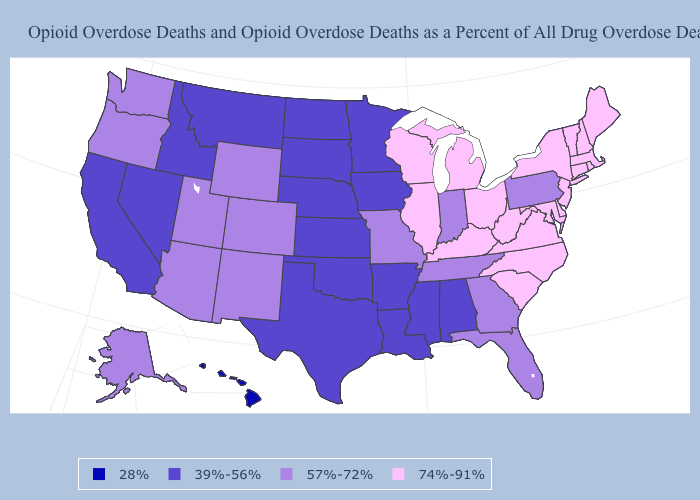What is the value of Virginia?
Short answer required. 74%-91%. What is the lowest value in the USA?
Short answer required. 28%. Name the states that have a value in the range 28%?
Give a very brief answer. Hawaii. Which states hav the highest value in the Northeast?
Write a very short answer. Connecticut, Maine, Massachusetts, New Hampshire, New Jersey, New York, Rhode Island, Vermont. Name the states that have a value in the range 39%-56%?
Give a very brief answer. Alabama, Arkansas, California, Idaho, Iowa, Kansas, Louisiana, Minnesota, Mississippi, Montana, Nebraska, Nevada, North Dakota, Oklahoma, South Dakota, Texas. Name the states that have a value in the range 57%-72%?
Keep it brief. Alaska, Arizona, Colorado, Florida, Georgia, Indiana, Missouri, New Mexico, Oregon, Pennsylvania, Tennessee, Utah, Washington, Wyoming. Name the states that have a value in the range 74%-91%?
Short answer required. Connecticut, Delaware, Illinois, Kentucky, Maine, Maryland, Massachusetts, Michigan, New Hampshire, New Jersey, New York, North Carolina, Ohio, Rhode Island, South Carolina, Vermont, Virginia, West Virginia, Wisconsin. Name the states that have a value in the range 74%-91%?
Answer briefly. Connecticut, Delaware, Illinois, Kentucky, Maine, Maryland, Massachusetts, Michigan, New Hampshire, New Jersey, New York, North Carolina, Ohio, Rhode Island, South Carolina, Vermont, Virginia, West Virginia, Wisconsin. Name the states that have a value in the range 74%-91%?
Be succinct. Connecticut, Delaware, Illinois, Kentucky, Maine, Maryland, Massachusetts, Michigan, New Hampshire, New Jersey, New York, North Carolina, Ohio, Rhode Island, South Carolina, Vermont, Virginia, West Virginia, Wisconsin. Name the states that have a value in the range 39%-56%?
Be succinct. Alabama, Arkansas, California, Idaho, Iowa, Kansas, Louisiana, Minnesota, Mississippi, Montana, Nebraska, Nevada, North Dakota, Oklahoma, South Dakota, Texas. What is the value of Colorado?
Concise answer only. 57%-72%. Name the states that have a value in the range 74%-91%?
Concise answer only. Connecticut, Delaware, Illinois, Kentucky, Maine, Maryland, Massachusetts, Michigan, New Hampshire, New Jersey, New York, North Carolina, Ohio, Rhode Island, South Carolina, Vermont, Virginia, West Virginia, Wisconsin. Name the states that have a value in the range 28%?
Quick response, please. Hawaii. What is the lowest value in states that border Louisiana?
Give a very brief answer. 39%-56%. 